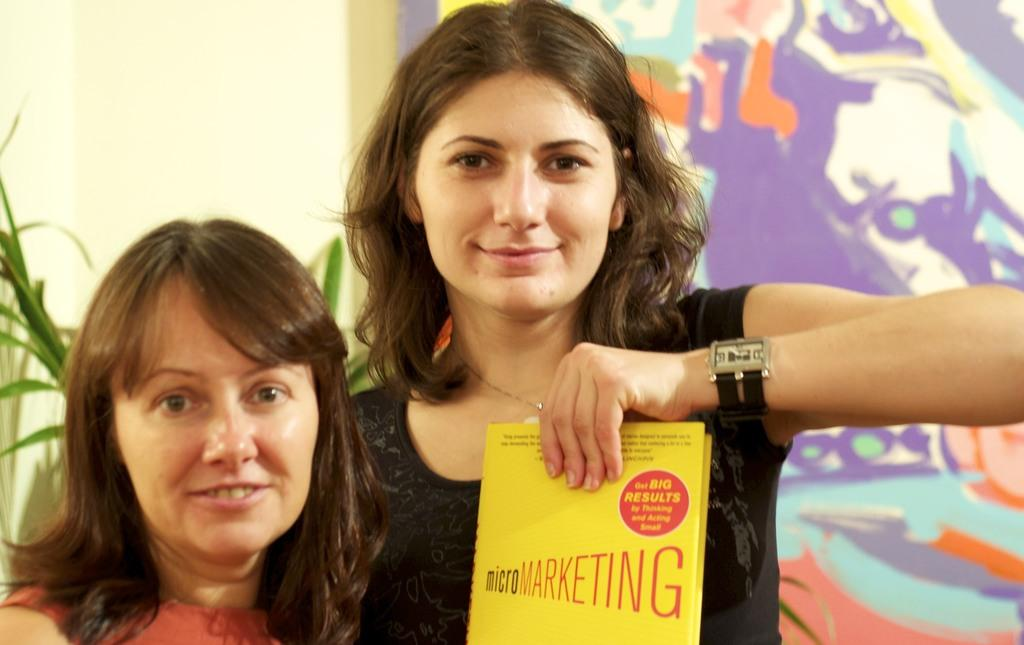<image>
Present a compact description of the photo's key features. A woman holds a yellow book about micromarketing. 